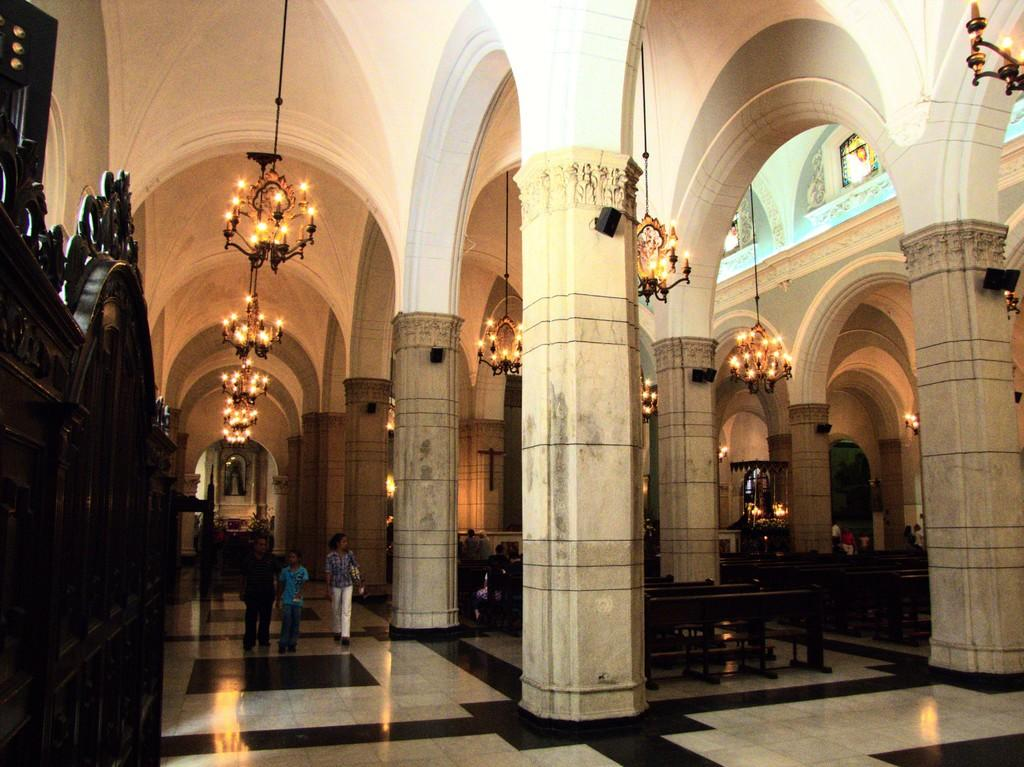What type of architectural feature can be seen in the image? There are pillars in the image. What type of seating is available in the image? There are benches in the image. Are there any people present in the image? Yes, there are people in the image. What can be seen under the people's feet in the image? The floor is visible in the image. What type of lighting is present in the background of the image? There are chandeliers in the background of the image. What color is the wall in the background of the image? The wall in the background is white. What type of garden can be seen in the image? There is no garden present in the image. What year is depicted in the image? The image does not depict a specific year; it is a static representation of the scene. 